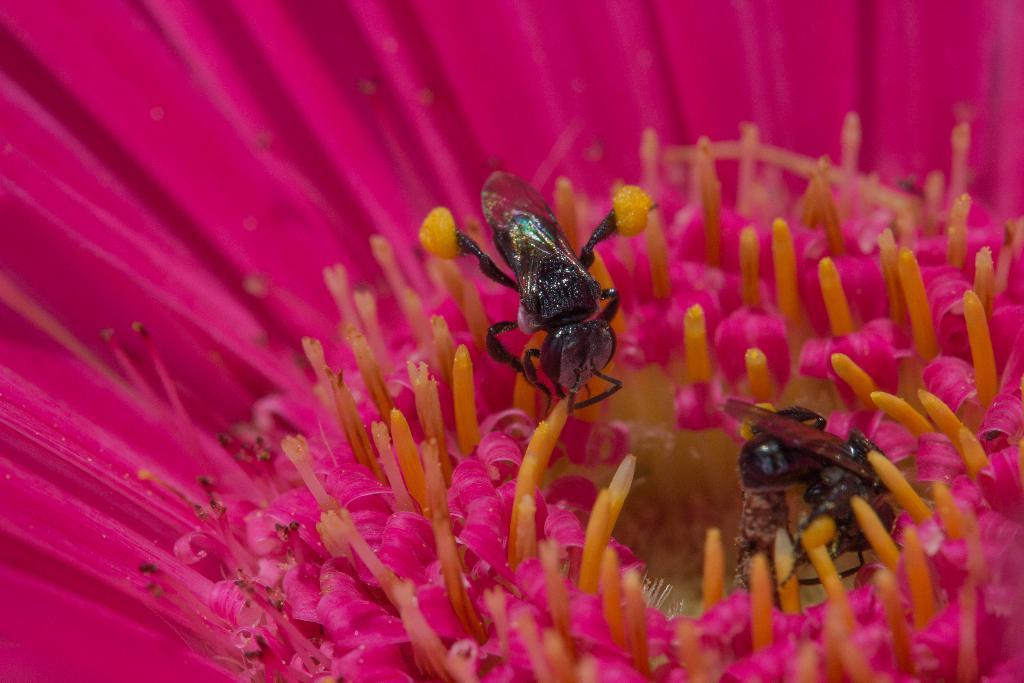What is present in the image? There is a flower in the image. What is the color of the flower? The flower is pink in color. Are there any other creatures or insects present on the flower? Yes, there are flies on the flower. What reason does the flower have for driving a car in the image? The flower does not have a reason for driving a car in the image, as flowers are not capable of driving cars. 